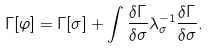<formula> <loc_0><loc_0><loc_500><loc_500>\Gamma [ \varphi ] = \Gamma [ \sigma ] + \int \frac { \delta \Gamma } { \delta \sigma } \lambda ^ { - 1 } _ { \sigma } \frac { \delta \Gamma } { \delta \sigma } .</formula> 